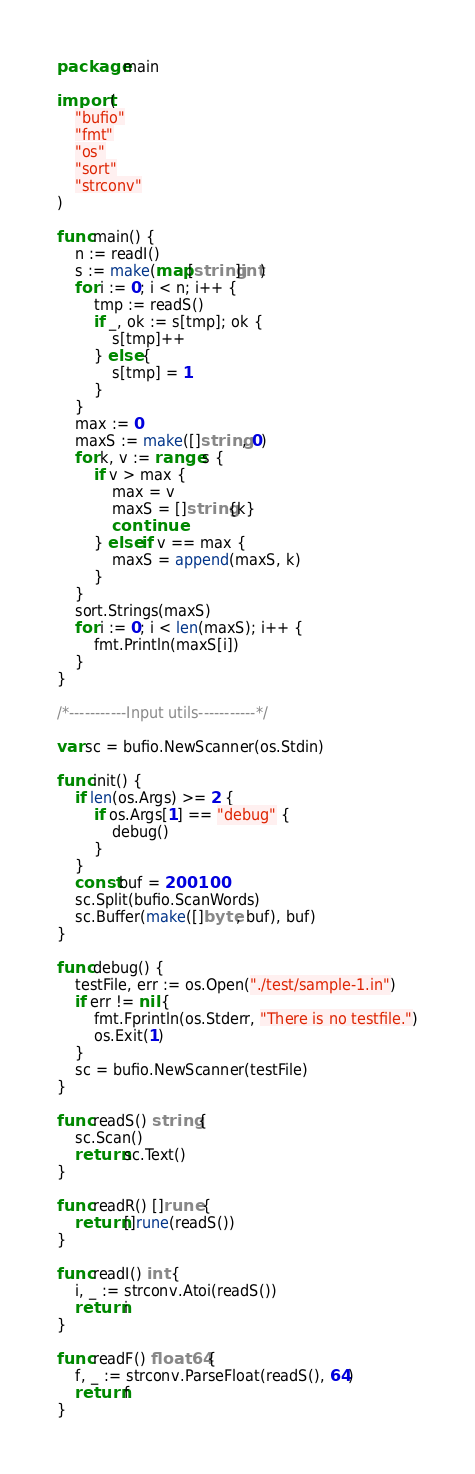<code> <loc_0><loc_0><loc_500><loc_500><_Go_>package main

import (
	"bufio"
	"fmt"
	"os"
	"sort"
	"strconv"
)

func main() {
	n := readI()
	s := make(map[string]int)
	for i := 0; i < n; i++ {
		tmp := readS()
		if _, ok := s[tmp]; ok {
			s[tmp]++
		} else {
			s[tmp] = 1
		}
	}
	max := 0
	maxS := make([]string, 0)
	for k, v := range s {
		if v > max {
			max = v
			maxS = []string{k}
			continue
		} else if v == max {
			maxS = append(maxS, k)
		}
	}
	sort.Strings(maxS)
	for i := 0; i < len(maxS); i++ {
		fmt.Println(maxS[i])
	}
}

/*-----------Input utils-----------*/

var sc = bufio.NewScanner(os.Stdin)

func init() {
	if len(os.Args) >= 2 {
		if os.Args[1] == "debug" {
			debug()
		}
	}
	const buf = 200100
	sc.Split(bufio.ScanWords)
	sc.Buffer(make([]byte, buf), buf)
}

func debug() {
	testFile, err := os.Open("./test/sample-1.in")
	if err != nil {
		fmt.Fprintln(os.Stderr, "There is no testfile.")
		os.Exit(1)
	}
	sc = bufio.NewScanner(testFile)
}

func readS() string {
	sc.Scan()
	return sc.Text()
}

func readR() []rune {
	return []rune(readS())
}

func readI() int {
	i, _ := strconv.Atoi(readS())
	return i
}

func readF() float64 {
	f, _ := strconv.ParseFloat(readS(), 64)
	return f
}
</code> 